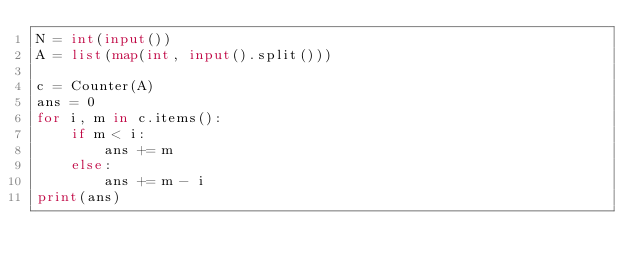Convert code to text. <code><loc_0><loc_0><loc_500><loc_500><_Python_>N = int(input())
A = list(map(int, input().split()))

c = Counter(A)
ans = 0
for i, m in c.items():
    if m < i:
        ans += m
    else:
        ans += m - i
print(ans)</code> 